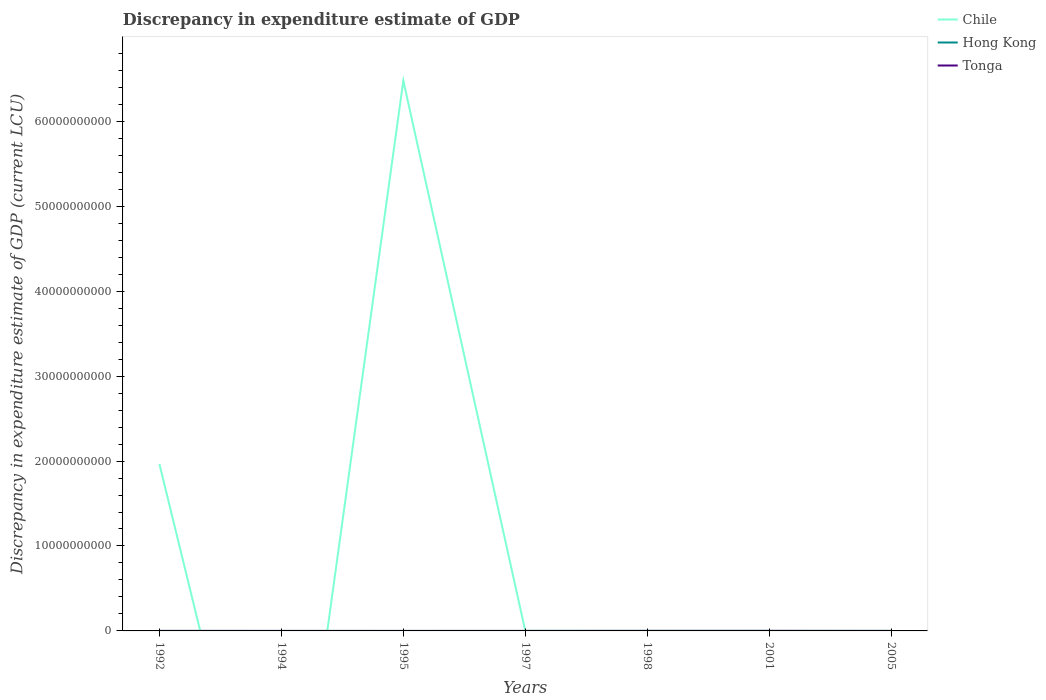What is the total discrepancy in expenditure estimate of GDP in Hong Kong in the graph?
Give a very brief answer. 0. What is the difference between the highest and the second highest discrepancy in expenditure estimate of GDP in Chile?
Your answer should be very brief. 6.48e+1. Is the discrepancy in expenditure estimate of GDP in Chile strictly greater than the discrepancy in expenditure estimate of GDP in Tonga over the years?
Your response must be concise. No. How many years are there in the graph?
Ensure brevity in your answer.  7. What is the difference between two consecutive major ticks on the Y-axis?
Your response must be concise. 1.00e+1. Are the values on the major ticks of Y-axis written in scientific E-notation?
Your response must be concise. No. How many legend labels are there?
Ensure brevity in your answer.  3. How are the legend labels stacked?
Your answer should be compact. Vertical. What is the title of the graph?
Your answer should be very brief. Discrepancy in expenditure estimate of GDP. What is the label or title of the X-axis?
Provide a short and direct response. Years. What is the label or title of the Y-axis?
Give a very brief answer. Discrepancy in expenditure estimate of GDP (current LCU). What is the Discrepancy in expenditure estimate of GDP (current LCU) of Chile in 1992?
Your answer should be very brief. 1.96e+1. What is the Discrepancy in expenditure estimate of GDP (current LCU) in Hong Kong in 1992?
Keep it short and to the point. 0. What is the Discrepancy in expenditure estimate of GDP (current LCU) in Tonga in 1992?
Keep it short and to the point. 3e-9. What is the Discrepancy in expenditure estimate of GDP (current LCU) of Chile in 1994?
Offer a very short reply. 0. What is the Discrepancy in expenditure estimate of GDP (current LCU) of Hong Kong in 1994?
Ensure brevity in your answer.  0. What is the Discrepancy in expenditure estimate of GDP (current LCU) of Chile in 1995?
Your answer should be very brief. 6.48e+1. What is the Discrepancy in expenditure estimate of GDP (current LCU) in Hong Kong in 1995?
Your response must be concise. 0. What is the Discrepancy in expenditure estimate of GDP (current LCU) in Chile in 1997?
Give a very brief answer. 1.00e+06. What is the Discrepancy in expenditure estimate of GDP (current LCU) in Hong Kong in 1997?
Ensure brevity in your answer.  2e-5. What is the Discrepancy in expenditure estimate of GDP (current LCU) in Tonga in 1997?
Provide a short and direct response. 0. What is the Discrepancy in expenditure estimate of GDP (current LCU) of Hong Kong in 1998?
Your response must be concise. 8e-5. What is the Discrepancy in expenditure estimate of GDP (current LCU) of Tonga in 1998?
Keep it short and to the point. 2.83e+06. What is the Discrepancy in expenditure estimate of GDP (current LCU) in Hong Kong in 2001?
Ensure brevity in your answer.  0. What is the Discrepancy in expenditure estimate of GDP (current LCU) of Tonga in 2001?
Ensure brevity in your answer.  6.20e+06. What is the Discrepancy in expenditure estimate of GDP (current LCU) in Tonga in 2005?
Your answer should be compact. 0. Across all years, what is the maximum Discrepancy in expenditure estimate of GDP (current LCU) in Chile?
Make the answer very short. 6.48e+1. Across all years, what is the maximum Discrepancy in expenditure estimate of GDP (current LCU) in Hong Kong?
Keep it short and to the point. 0. Across all years, what is the maximum Discrepancy in expenditure estimate of GDP (current LCU) of Tonga?
Ensure brevity in your answer.  6.20e+06. Across all years, what is the minimum Discrepancy in expenditure estimate of GDP (current LCU) of Chile?
Give a very brief answer. 0. Across all years, what is the minimum Discrepancy in expenditure estimate of GDP (current LCU) of Tonga?
Give a very brief answer. 0. What is the total Discrepancy in expenditure estimate of GDP (current LCU) in Chile in the graph?
Your response must be concise. 8.44e+1. What is the total Discrepancy in expenditure estimate of GDP (current LCU) of Hong Kong in the graph?
Provide a succinct answer. 0. What is the total Discrepancy in expenditure estimate of GDP (current LCU) of Tonga in the graph?
Offer a terse response. 9.03e+06. What is the difference between the Discrepancy in expenditure estimate of GDP (current LCU) in Chile in 1992 and that in 1995?
Keep it short and to the point. -4.51e+1. What is the difference between the Discrepancy in expenditure estimate of GDP (current LCU) in Chile in 1992 and that in 1997?
Ensure brevity in your answer.  1.96e+1. What is the difference between the Discrepancy in expenditure estimate of GDP (current LCU) in Chile in 1992 and that in 1998?
Offer a terse response. 1.96e+1. What is the difference between the Discrepancy in expenditure estimate of GDP (current LCU) of Tonga in 1992 and that in 1998?
Keep it short and to the point. -2.83e+06. What is the difference between the Discrepancy in expenditure estimate of GDP (current LCU) of Chile in 1992 and that in 2001?
Provide a short and direct response. 1.96e+1. What is the difference between the Discrepancy in expenditure estimate of GDP (current LCU) of Tonga in 1992 and that in 2001?
Ensure brevity in your answer.  -6.20e+06. What is the difference between the Discrepancy in expenditure estimate of GDP (current LCU) in Chile in 1995 and that in 1997?
Ensure brevity in your answer.  6.48e+1. What is the difference between the Discrepancy in expenditure estimate of GDP (current LCU) of Hong Kong in 1995 and that in 1997?
Make the answer very short. 0. What is the difference between the Discrepancy in expenditure estimate of GDP (current LCU) of Chile in 1995 and that in 1998?
Your answer should be compact. 6.48e+1. What is the difference between the Discrepancy in expenditure estimate of GDP (current LCU) of Chile in 1995 and that in 2001?
Offer a very short reply. 6.48e+1. What is the difference between the Discrepancy in expenditure estimate of GDP (current LCU) of Hong Kong in 1995 and that in 2001?
Your response must be concise. 0. What is the difference between the Discrepancy in expenditure estimate of GDP (current LCU) of Chile in 1997 and that in 1998?
Provide a short and direct response. -1.00e+06. What is the difference between the Discrepancy in expenditure estimate of GDP (current LCU) of Hong Kong in 1997 and that in 1998?
Provide a short and direct response. -0. What is the difference between the Discrepancy in expenditure estimate of GDP (current LCU) of Chile in 1997 and that in 2001?
Provide a succinct answer. 1.00e+06. What is the difference between the Discrepancy in expenditure estimate of GDP (current LCU) of Hong Kong in 1997 and that in 2001?
Ensure brevity in your answer.  -0. What is the difference between the Discrepancy in expenditure estimate of GDP (current LCU) of Chile in 1998 and that in 2001?
Your answer should be compact. 2.00e+06. What is the difference between the Discrepancy in expenditure estimate of GDP (current LCU) in Tonga in 1998 and that in 2001?
Your answer should be very brief. -3.36e+06. What is the difference between the Discrepancy in expenditure estimate of GDP (current LCU) in Chile in 1992 and the Discrepancy in expenditure estimate of GDP (current LCU) in Hong Kong in 1994?
Ensure brevity in your answer.  1.96e+1. What is the difference between the Discrepancy in expenditure estimate of GDP (current LCU) of Chile in 1992 and the Discrepancy in expenditure estimate of GDP (current LCU) of Hong Kong in 1995?
Make the answer very short. 1.96e+1. What is the difference between the Discrepancy in expenditure estimate of GDP (current LCU) of Chile in 1992 and the Discrepancy in expenditure estimate of GDP (current LCU) of Hong Kong in 1997?
Give a very brief answer. 1.96e+1. What is the difference between the Discrepancy in expenditure estimate of GDP (current LCU) of Chile in 1992 and the Discrepancy in expenditure estimate of GDP (current LCU) of Hong Kong in 1998?
Keep it short and to the point. 1.96e+1. What is the difference between the Discrepancy in expenditure estimate of GDP (current LCU) in Chile in 1992 and the Discrepancy in expenditure estimate of GDP (current LCU) in Tonga in 1998?
Make the answer very short. 1.96e+1. What is the difference between the Discrepancy in expenditure estimate of GDP (current LCU) of Chile in 1992 and the Discrepancy in expenditure estimate of GDP (current LCU) of Hong Kong in 2001?
Your answer should be very brief. 1.96e+1. What is the difference between the Discrepancy in expenditure estimate of GDP (current LCU) of Chile in 1992 and the Discrepancy in expenditure estimate of GDP (current LCU) of Tonga in 2001?
Ensure brevity in your answer.  1.96e+1. What is the difference between the Discrepancy in expenditure estimate of GDP (current LCU) of Hong Kong in 1994 and the Discrepancy in expenditure estimate of GDP (current LCU) of Tonga in 1998?
Offer a terse response. -2.83e+06. What is the difference between the Discrepancy in expenditure estimate of GDP (current LCU) in Hong Kong in 1994 and the Discrepancy in expenditure estimate of GDP (current LCU) in Tonga in 2001?
Make the answer very short. -6.20e+06. What is the difference between the Discrepancy in expenditure estimate of GDP (current LCU) of Chile in 1995 and the Discrepancy in expenditure estimate of GDP (current LCU) of Hong Kong in 1997?
Offer a very short reply. 6.48e+1. What is the difference between the Discrepancy in expenditure estimate of GDP (current LCU) of Chile in 1995 and the Discrepancy in expenditure estimate of GDP (current LCU) of Hong Kong in 1998?
Give a very brief answer. 6.48e+1. What is the difference between the Discrepancy in expenditure estimate of GDP (current LCU) of Chile in 1995 and the Discrepancy in expenditure estimate of GDP (current LCU) of Tonga in 1998?
Your response must be concise. 6.48e+1. What is the difference between the Discrepancy in expenditure estimate of GDP (current LCU) in Hong Kong in 1995 and the Discrepancy in expenditure estimate of GDP (current LCU) in Tonga in 1998?
Make the answer very short. -2.83e+06. What is the difference between the Discrepancy in expenditure estimate of GDP (current LCU) of Chile in 1995 and the Discrepancy in expenditure estimate of GDP (current LCU) of Hong Kong in 2001?
Offer a terse response. 6.48e+1. What is the difference between the Discrepancy in expenditure estimate of GDP (current LCU) of Chile in 1995 and the Discrepancy in expenditure estimate of GDP (current LCU) of Tonga in 2001?
Make the answer very short. 6.48e+1. What is the difference between the Discrepancy in expenditure estimate of GDP (current LCU) of Hong Kong in 1995 and the Discrepancy in expenditure estimate of GDP (current LCU) of Tonga in 2001?
Offer a terse response. -6.20e+06. What is the difference between the Discrepancy in expenditure estimate of GDP (current LCU) in Chile in 1997 and the Discrepancy in expenditure estimate of GDP (current LCU) in Hong Kong in 1998?
Make the answer very short. 1.00e+06. What is the difference between the Discrepancy in expenditure estimate of GDP (current LCU) in Chile in 1997 and the Discrepancy in expenditure estimate of GDP (current LCU) in Tonga in 1998?
Provide a short and direct response. -1.83e+06. What is the difference between the Discrepancy in expenditure estimate of GDP (current LCU) in Hong Kong in 1997 and the Discrepancy in expenditure estimate of GDP (current LCU) in Tonga in 1998?
Provide a short and direct response. -2.83e+06. What is the difference between the Discrepancy in expenditure estimate of GDP (current LCU) of Chile in 1997 and the Discrepancy in expenditure estimate of GDP (current LCU) of Hong Kong in 2001?
Ensure brevity in your answer.  1.00e+06. What is the difference between the Discrepancy in expenditure estimate of GDP (current LCU) of Chile in 1997 and the Discrepancy in expenditure estimate of GDP (current LCU) of Tonga in 2001?
Offer a terse response. -5.20e+06. What is the difference between the Discrepancy in expenditure estimate of GDP (current LCU) of Hong Kong in 1997 and the Discrepancy in expenditure estimate of GDP (current LCU) of Tonga in 2001?
Give a very brief answer. -6.20e+06. What is the difference between the Discrepancy in expenditure estimate of GDP (current LCU) of Chile in 1998 and the Discrepancy in expenditure estimate of GDP (current LCU) of Hong Kong in 2001?
Your response must be concise. 2.00e+06. What is the difference between the Discrepancy in expenditure estimate of GDP (current LCU) of Chile in 1998 and the Discrepancy in expenditure estimate of GDP (current LCU) of Tonga in 2001?
Offer a terse response. -4.20e+06. What is the difference between the Discrepancy in expenditure estimate of GDP (current LCU) of Hong Kong in 1998 and the Discrepancy in expenditure estimate of GDP (current LCU) of Tonga in 2001?
Offer a very short reply. -6.20e+06. What is the average Discrepancy in expenditure estimate of GDP (current LCU) in Chile per year?
Ensure brevity in your answer.  1.21e+1. What is the average Discrepancy in expenditure estimate of GDP (current LCU) of Hong Kong per year?
Your answer should be very brief. 0. What is the average Discrepancy in expenditure estimate of GDP (current LCU) of Tonga per year?
Make the answer very short. 1.29e+06. In the year 1992, what is the difference between the Discrepancy in expenditure estimate of GDP (current LCU) in Chile and Discrepancy in expenditure estimate of GDP (current LCU) in Tonga?
Keep it short and to the point. 1.96e+1. In the year 1995, what is the difference between the Discrepancy in expenditure estimate of GDP (current LCU) of Chile and Discrepancy in expenditure estimate of GDP (current LCU) of Hong Kong?
Offer a very short reply. 6.48e+1. In the year 1998, what is the difference between the Discrepancy in expenditure estimate of GDP (current LCU) in Chile and Discrepancy in expenditure estimate of GDP (current LCU) in Hong Kong?
Provide a short and direct response. 2.00e+06. In the year 1998, what is the difference between the Discrepancy in expenditure estimate of GDP (current LCU) in Chile and Discrepancy in expenditure estimate of GDP (current LCU) in Tonga?
Keep it short and to the point. -8.34e+05. In the year 1998, what is the difference between the Discrepancy in expenditure estimate of GDP (current LCU) in Hong Kong and Discrepancy in expenditure estimate of GDP (current LCU) in Tonga?
Provide a succinct answer. -2.83e+06. In the year 2001, what is the difference between the Discrepancy in expenditure estimate of GDP (current LCU) of Chile and Discrepancy in expenditure estimate of GDP (current LCU) of Hong Kong?
Ensure brevity in your answer.  100. In the year 2001, what is the difference between the Discrepancy in expenditure estimate of GDP (current LCU) of Chile and Discrepancy in expenditure estimate of GDP (current LCU) of Tonga?
Provide a short and direct response. -6.20e+06. In the year 2001, what is the difference between the Discrepancy in expenditure estimate of GDP (current LCU) in Hong Kong and Discrepancy in expenditure estimate of GDP (current LCU) in Tonga?
Your answer should be very brief. -6.20e+06. What is the ratio of the Discrepancy in expenditure estimate of GDP (current LCU) of Chile in 1992 to that in 1995?
Ensure brevity in your answer.  0.3. What is the ratio of the Discrepancy in expenditure estimate of GDP (current LCU) in Chile in 1992 to that in 1997?
Provide a short and direct response. 1.96e+04. What is the ratio of the Discrepancy in expenditure estimate of GDP (current LCU) in Chile in 1992 to that in 1998?
Make the answer very short. 9817.5. What is the ratio of the Discrepancy in expenditure estimate of GDP (current LCU) in Chile in 1992 to that in 2001?
Offer a very short reply. 1.96e+08. What is the ratio of the Discrepancy in expenditure estimate of GDP (current LCU) of Tonga in 1992 to that in 2001?
Provide a short and direct response. 0. What is the ratio of the Discrepancy in expenditure estimate of GDP (current LCU) of Hong Kong in 1994 to that in 1995?
Ensure brevity in your answer.  1.62. What is the ratio of the Discrepancy in expenditure estimate of GDP (current LCU) of Hong Kong in 1994 to that in 1998?
Offer a very short reply. 3.75. What is the ratio of the Discrepancy in expenditure estimate of GDP (current LCU) in Hong Kong in 1994 to that in 2001?
Your answer should be very brief. 2.5. What is the ratio of the Discrepancy in expenditure estimate of GDP (current LCU) in Chile in 1995 to that in 1997?
Offer a very short reply. 6.48e+04. What is the ratio of the Discrepancy in expenditure estimate of GDP (current LCU) in Hong Kong in 1995 to that in 1997?
Keep it short and to the point. 9.25. What is the ratio of the Discrepancy in expenditure estimate of GDP (current LCU) of Chile in 1995 to that in 1998?
Give a very brief answer. 3.24e+04. What is the ratio of the Discrepancy in expenditure estimate of GDP (current LCU) of Hong Kong in 1995 to that in 1998?
Offer a terse response. 2.31. What is the ratio of the Discrepancy in expenditure estimate of GDP (current LCU) of Chile in 1995 to that in 2001?
Provide a succinct answer. 6.48e+08. What is the ratio of the Discrepancy in expenditure estimate of GDP (current LCU) in Hong Kong in 1995 to that in 2001?
Your response must be concise. 1.54. What is the ratio of the Discrepancy in expenditure estimate of GDP (current LCU) of Chile in 1997 to that in 1998?
Make the answer very short. 0.5. What is the ratio of the Discrepancy in expenditure estimate of GDP (current LCU) in Hong Kong in 1997 to that in 1998?
Your answer should be very brief. 0.25. What is the ratio of the Discrepancy in expenditure estimate of GDP (current LCU) in Chile in 1997 to that in 2001?
Ensure brevity in your answer.  10000. What is the ratio of the Discrepancy in expenditure estimate of GDP (current LCU) in Hong Kong in 1997 to that in 2001?
Offer a very short reply. 0.17. What is the ratio of the Discrepancy in expenditure estimate of GDP (current LCU) in Tonga in 1998 to that in 2001?
Keep it short and to the point. 0.46. What is the difference between the highest and the second highest Discrepancy in expenditure estimate of GDP (current LCU) of Chile?
Keep it short and to the point. 4.51e+1. What is the difference between the highest and the second highest Discrepancy in expenditure estimate of GDP (current LCU) of Hong Kong?
Your response must be concise. 0. What is the difference between the highest and the second highest Discrepancy in expenditure estimate of GDP (current LCU) of Tonga?
Your answer should be very brief. 3.36e+06. What is the difference between the highest and the lowest Discrepancy in expenditure estimate of GDP (current LCU) in Chile?
Offer a very short reply. 6.48e+1. What is the difference between the highest and the lowest Discrepancy in expenditure estimate of GDP (current LCU) of Tonga?
Provide a short and direct response. 6.20e+06. 